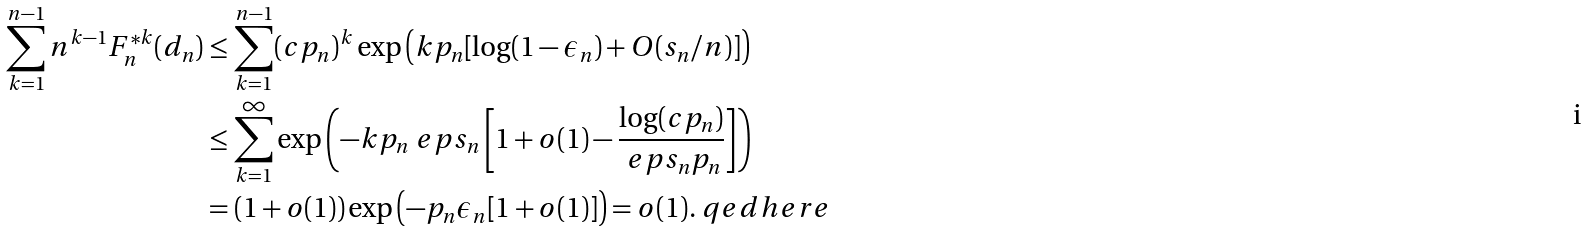Convert formula to latex. <formula><loc_0><loc_0><loc_500><loc_500>\sum _ { k = 1 } ^ { n - 1 } n ^ { k - 1 } F _ { n } ^ { * k } ( d _ { n } ) & \leq \sum _ { k = 1 } ^ { n - 1 } ( c p _ { n } ) ^ { k } \exp \left ( k p _ { n } [ \log ( 1 - \epsilon _ { n } ) + O ( s _ { n } / n ) ] \right ) \\ & \leq \sum _ { k = 1 } ^ { \infty } \exp \left ( - k p _ { n } \ e p s _ { n } \left [ 1 + o ( 1 ) - \frac { \log ( c p _ { n } ) } { \ e p s _ { n } p _ { n } } \right ] \right ) \\ & = ( 1 + o ( 1 ) ) \exp \left ( - p _ { n } \epsilon _ { n } [ 1 + o ( 1 ) ] \right ) = o ( 1 ) . \ q e d h e r e</formula> 